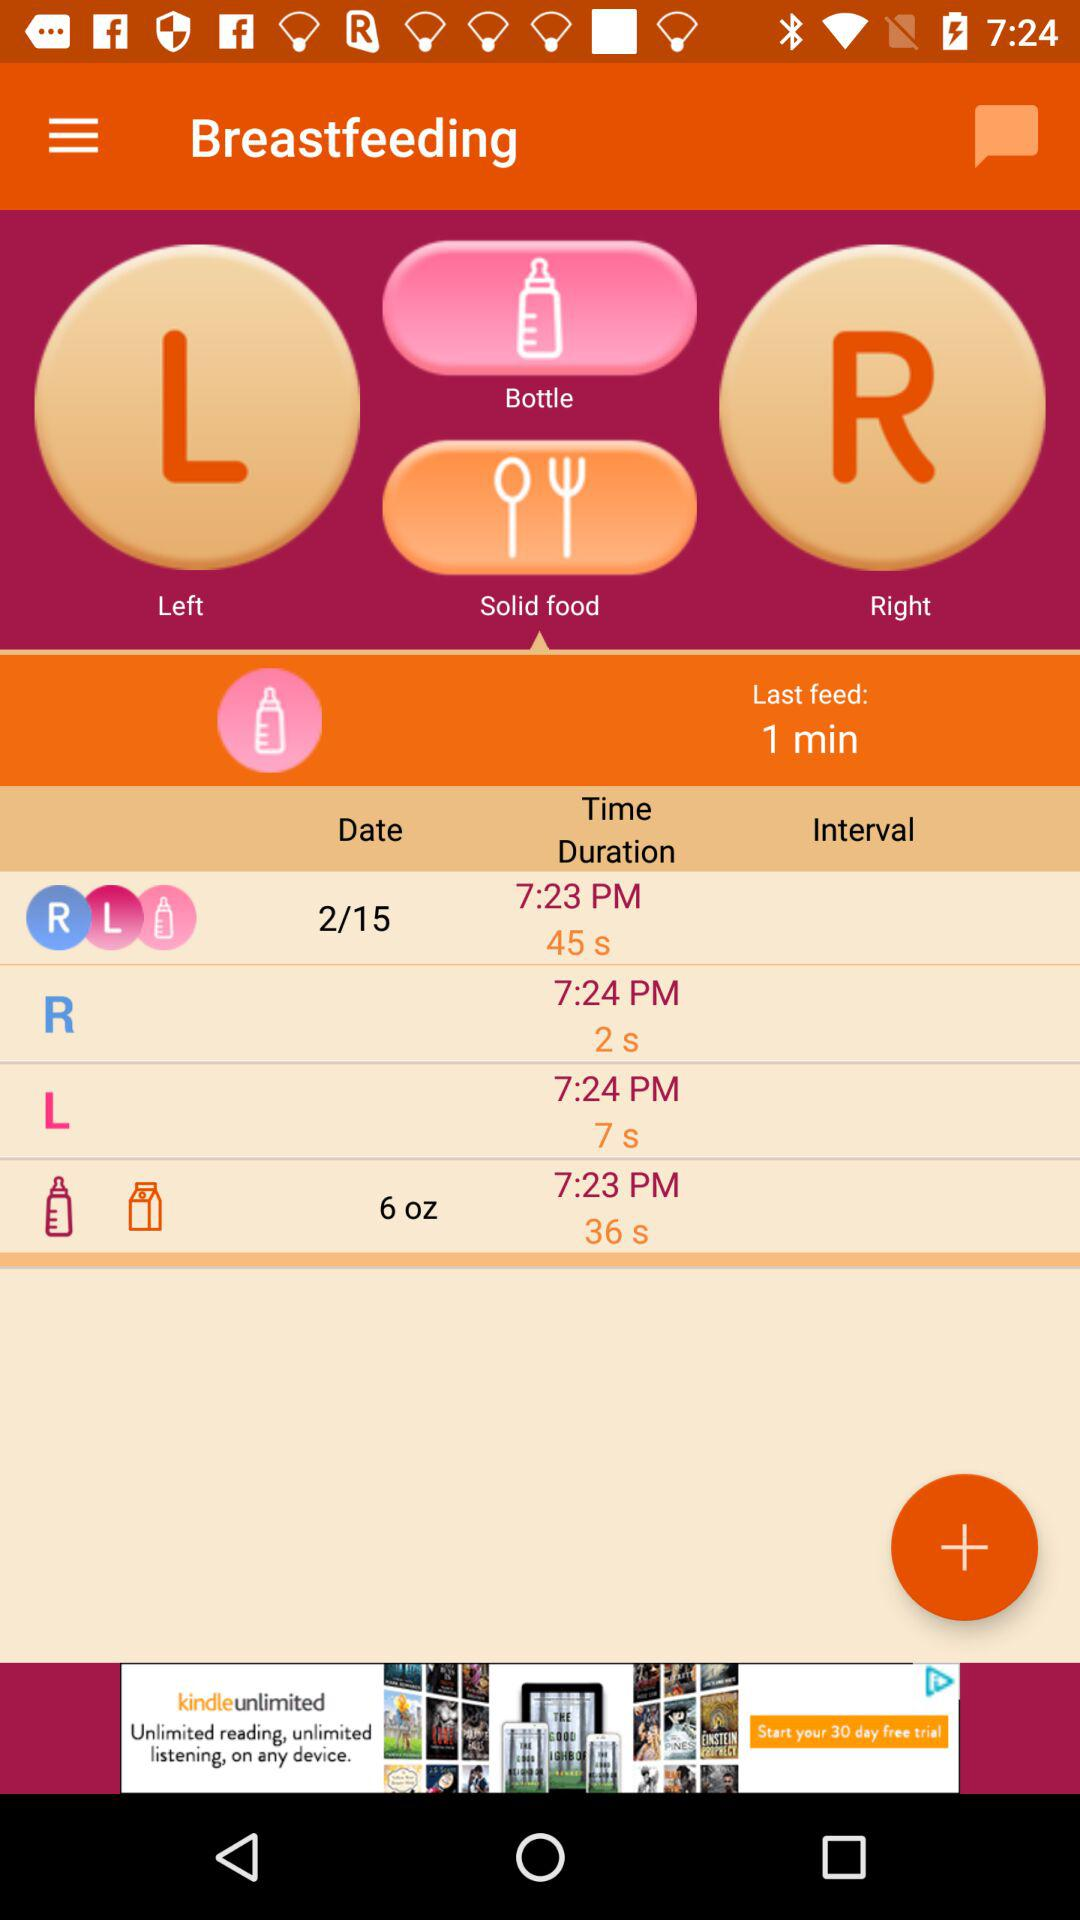What is the mentioned date? The mentioned date is February 15. 